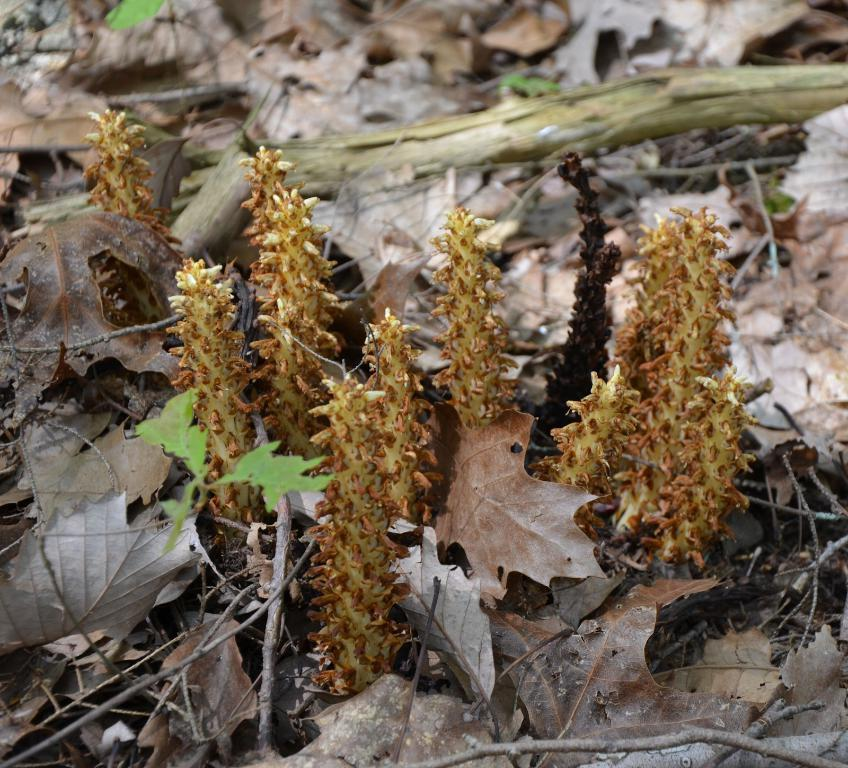What type of vegetation can be seen in the image? There are dried leaves and small plants in the image. Can you describe the condition of the vegetation? The dried leaves suggest that the plants may be withering or dead. What type of porter is carrying the wish on a voyage in the image? There is no porter, wish, or voyage depicted in the image; it only features dried leaves and small plants. 